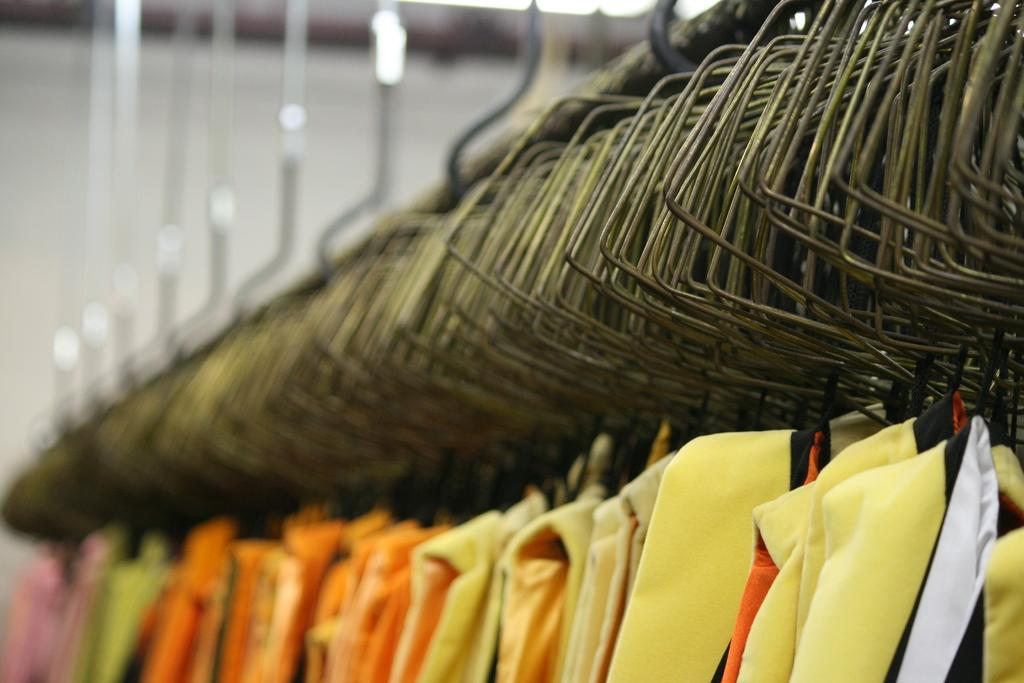What is the main subject of the image? The main subject of the image is many hangers. What else can be seen at the bottom of the image? There are many clothes at the bottom of the image. Can you describe the background on the left side of the image? The background on the left side of the image is blurred. What color is the crayon used to draw the clothes in the image? There is no crayon present in the image, as the clothes are real and not drawn. How much milk is visible in the image? There is no milk present in the image. 